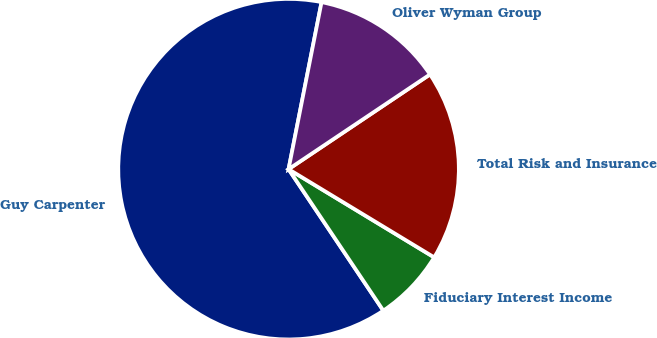Convert chart. <chart><loc_0><loc_0><loc_500><loc_500><pie_chart><fcel>Guy Carpenter<fcel>Fiduciary Interest Income<fcel>Total Risk and Insurance<fcel>Oliver Wyman Group<nl><fcel>62.5%<fcel>6.94%<fcel>18.06%<fcel>12.5%<nl></chart> 